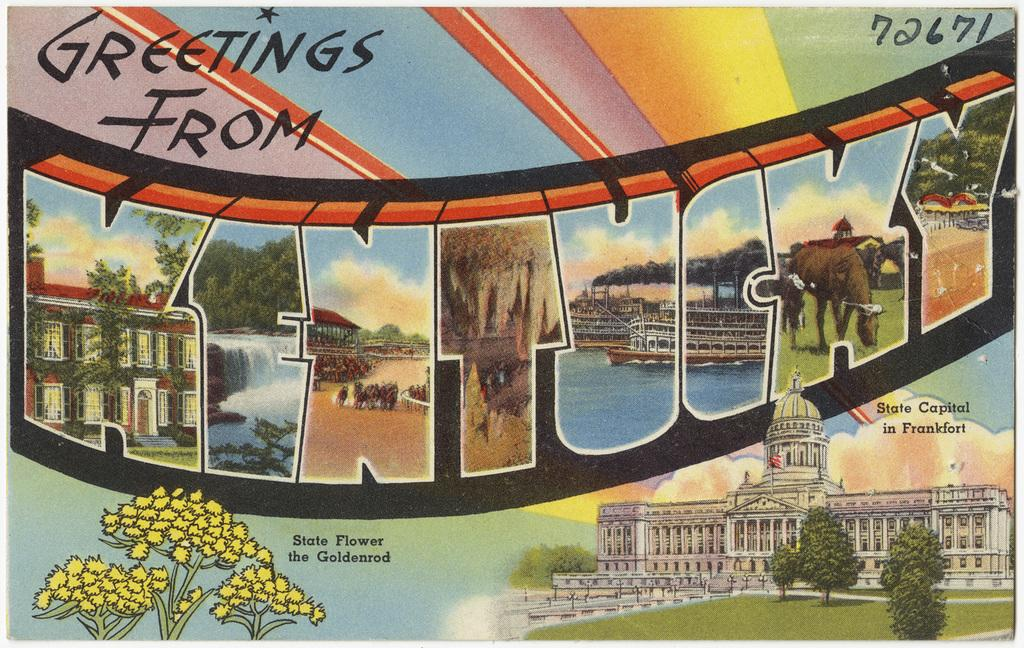<image>
Create a compact narrative representing the image presented. A postcard with a graphic that reads, "Greetings from Kentucky.: 